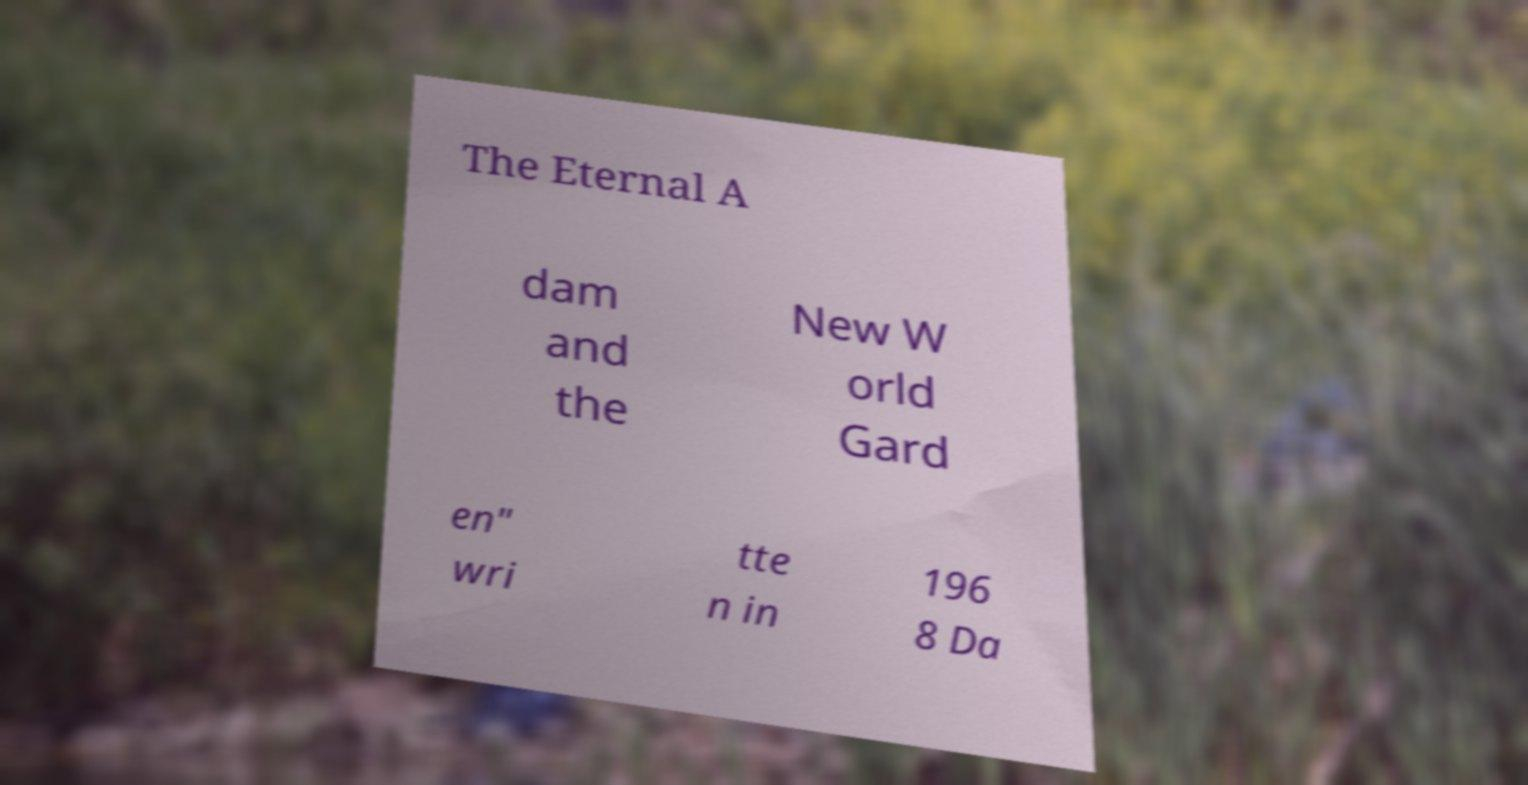Could you assist in decoding the text presented in this image and type it out clearly? The Eternal A dam and the New W orld Gard en" wri tte n in 196 8 Da 